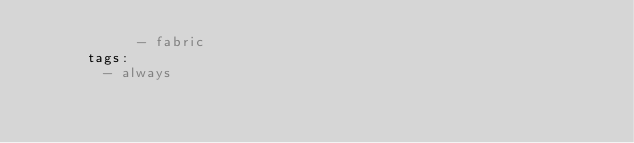<code> <loc_0><loc_0><loc_500><loc_500><_YAML_>            - fabric
      tags:
        - always</code> 